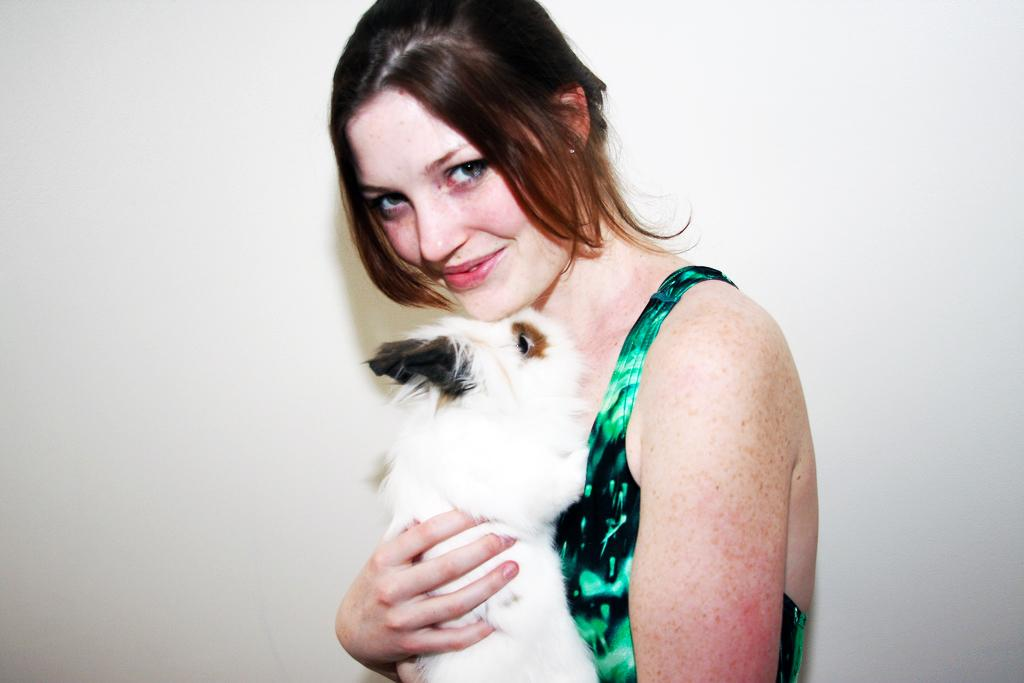Who is present in the image? There is a woman in the image. What is the woman holding in the image? The woman is holding an animal. What is the woman's facial expression in the image? The woman is smiling in the image. What color is the woman's top in the image? The woman is wearing a green top in the image. How many legs does the lumber have in the image? There is no lumber present in the image, so it is not possible to determine the number of legs it might have. 